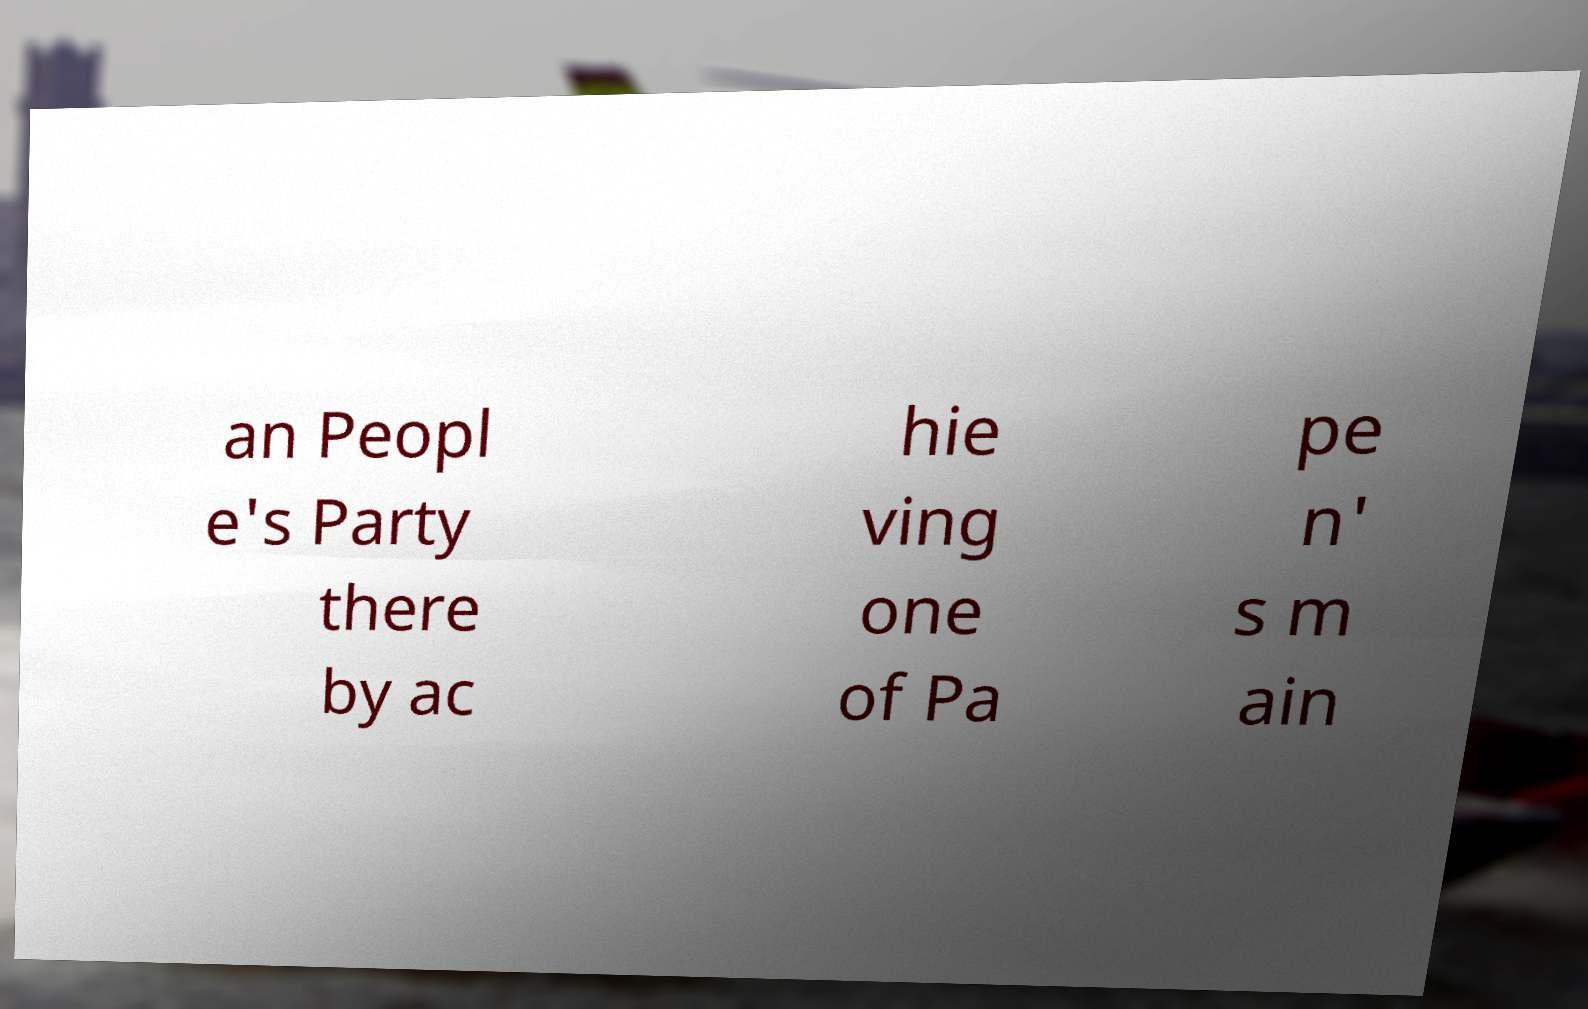Please read and relay the text visible in this image. What does it say? an Peopl e's Party there by ac hie ving one of Pa pe n' s m ain 